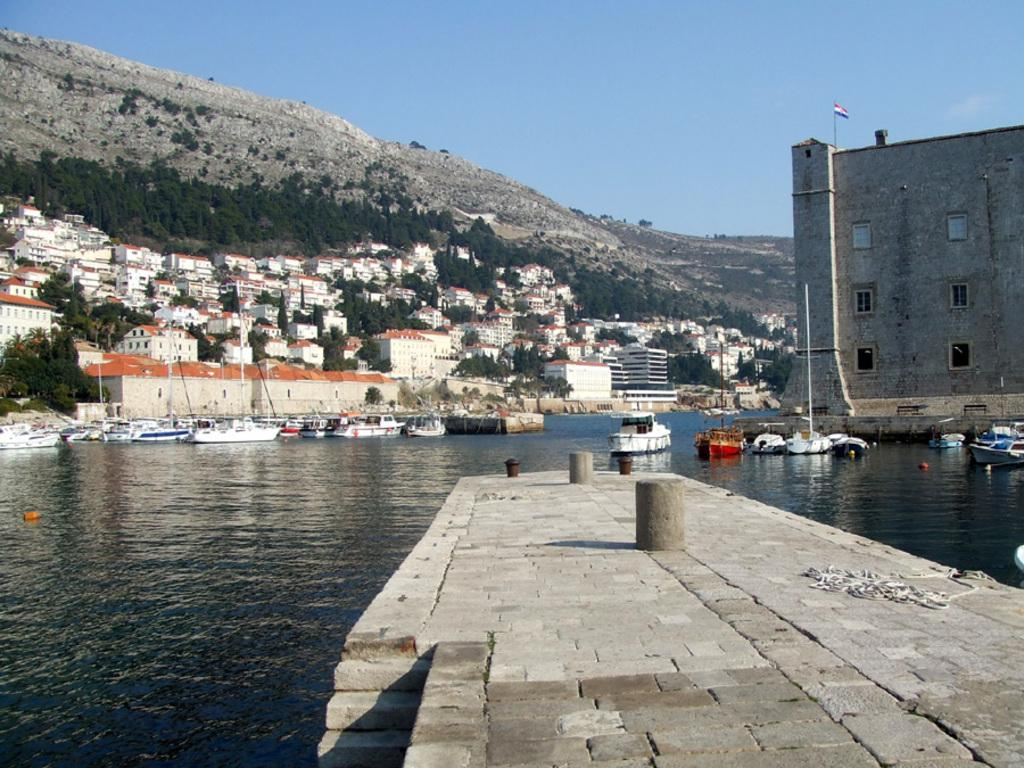What is on the water in the image? There are boats on the water in the image. What type of structures can be seen in the image? There are buildings in the image. What other natural elements are present in the image? There are trees in the image. What architectural features can be observed in the image? There are windows in the image. What geographical feature is visible in the distance? There are mountains in the image. What is attached to a pole in the image? There is a flag in the image. What is visible in the background of the image? The sky is visible in the background of the image. What type of rod is being used to catch fish in the image? There is no rod or fishing activity present in the image. Can you see an airplane flying in the sky in the image? There is no airplane visible in the image; only boats, buildings, trees, windows, mountains, a flag, and the sky are present. 